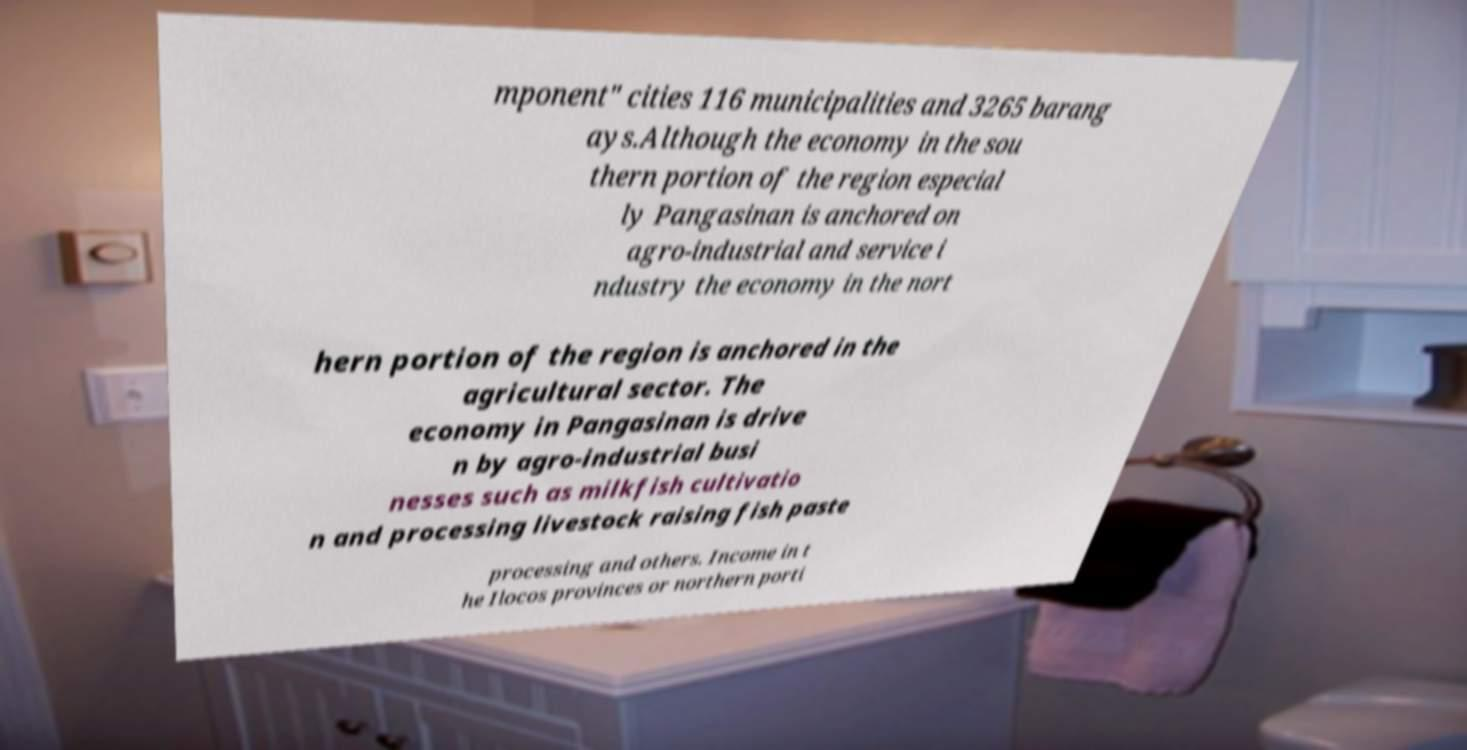I need the written content from this picture converted into text. Can you do that? mponent" cities 116 municipalities and 3265 barang ays.Although the economy in the sou thern portion of the region especial ly Pangasinan is anchored on agro-industrial and service i ndustry the economy in the nort hern portion of the region is anchored in the agricultural sector. The economy in Pangasinan is drive n by agro-industrial busi nesses such as milkfish cultivatio n and processing livestock raising fish paste processing and others. Income in t he Ilocos provinces or northern porti 